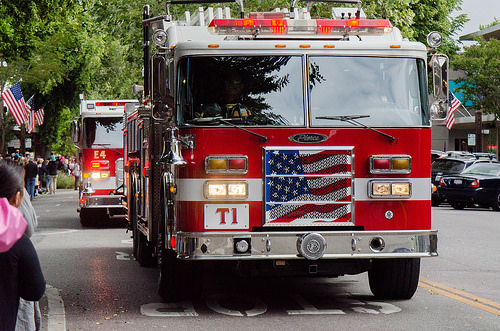<image>
Is there a truck behind the truck? No. The truck is not behind the truck. From this viewpoint, the truck appears to be positioned elsewhere in the scene. 